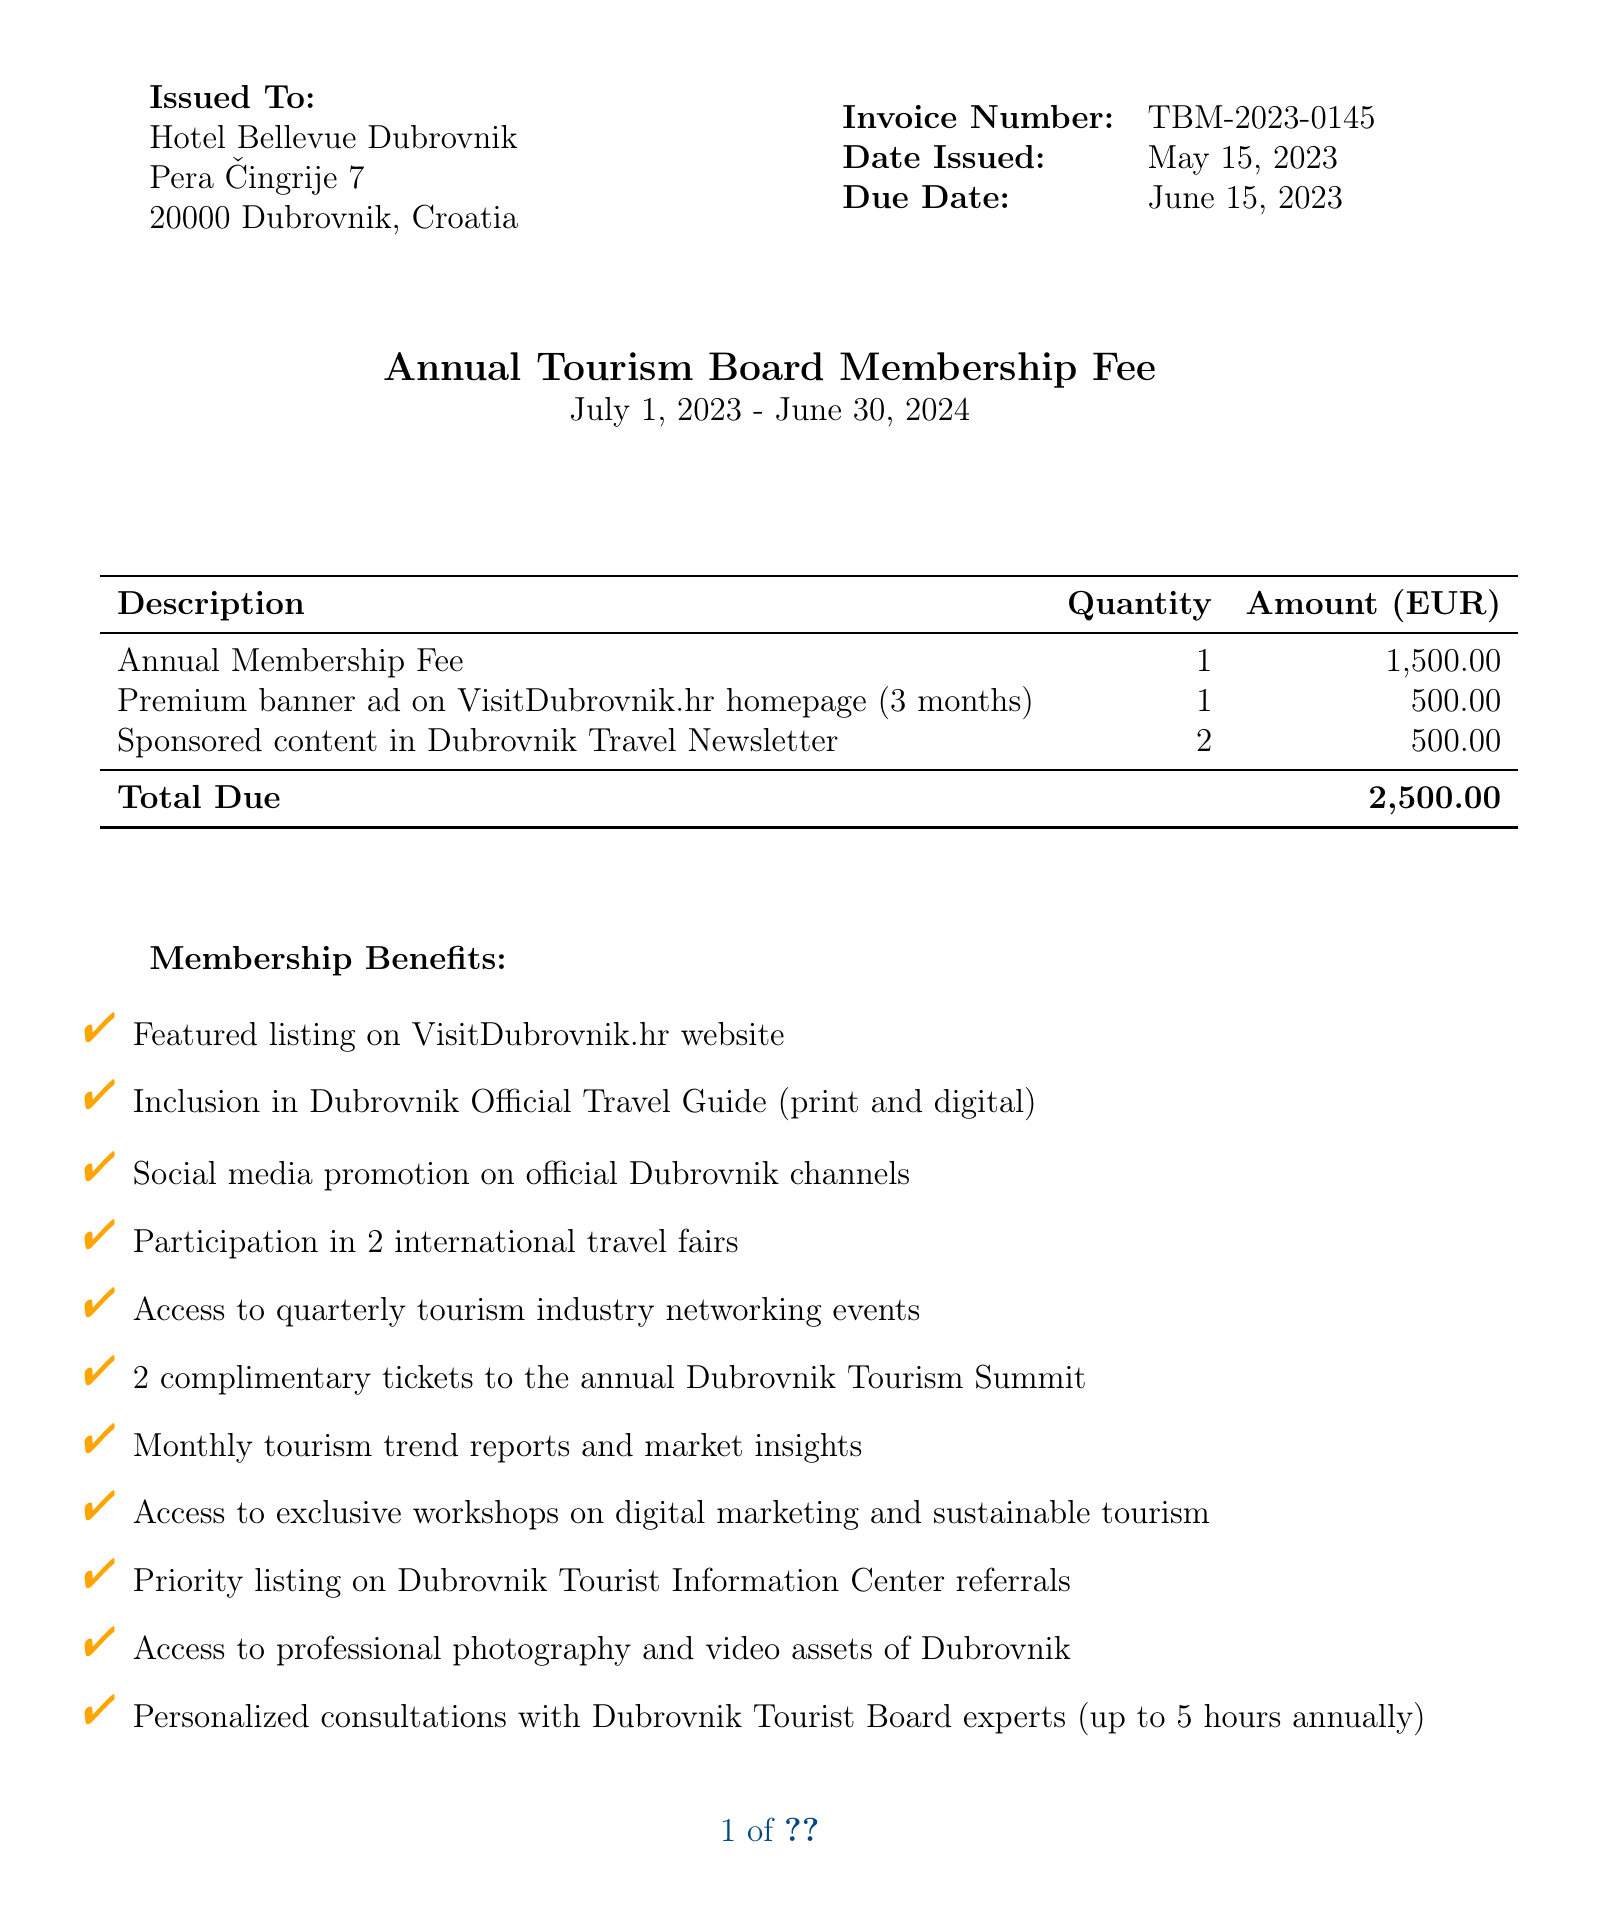What is the invoice number? The invoice number is listed as "TBM-2023-0145" in the document.
Answer: TBM-2023-0145 When was the invoice issued? The date the invoice was issued can be found in the document under "Date Issued."
Answer: May 15, 2023 What is the total amount due? The total due is calculated based on the membership fee and additional services listed.
Answer: 2,500.00 Who is the contact person for the membership? The document provides a contact name for inquiries related to the membership.
Answer: Ana Horvat What is the annual membership fee? The annual fee is specified in the membership fee section of the document.
Answer: 1,500 What benefits include marketing and promotion? This category lists the specific promotional activities offered as part of the membership.
Answer: Featured listing on VisitDubrovnik.hr website, Inclusion in Dubrovnik Official Travel Guide, Social media promotion on official channels, Participation in 2 international travel fairs How long is the membership period? The membership period specifies the duration for which the fee is applicable, mentioned in the membership fee section.
Answer: July 1, 2023 - June 30, 2024 What is the payment reference? The payment reference is essential for identifying payments against the invoice.
Answer: TBM-2023-0145 How many tickets are provided for the Dubrovnik Tourism Summit? The document clearly states how many tickets are included as part of the membership benefits.
Answer: 2 